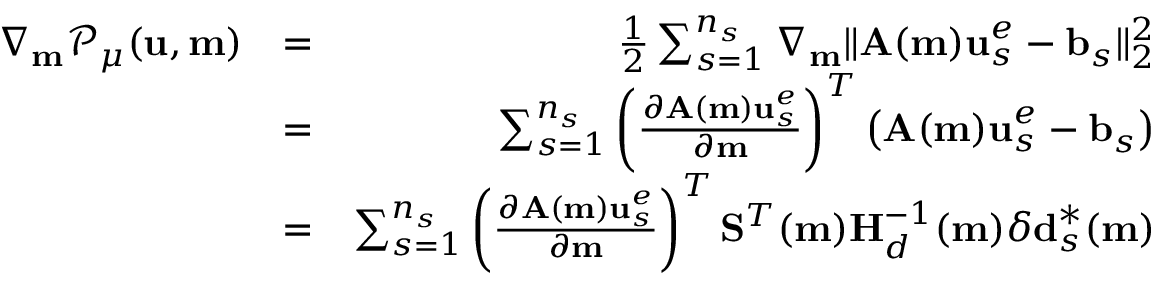<formula> <loc_0><loc_0><loc_500><loc_500>\begin{array} { r l r } { \nabla _ { m } \mathcal { P } _ { \mu } ( u , m ) } & { = } & { \frac { 1 } { 2 } \sum _ { s = 1 } ^ { n _ { s } } \nabla _ { m } \| A ( m ) u _ { s } ^ { e } - b _ { s } \| _ { 2 } ^ { 2 } } \\ & { = } & { \sum _ { s = 1 } ^ { n _ { s } } \left ( \frac { \partial A ( m ) u _ { s } ^ { e } } { \partial m } \right ) ^ { T } \left ( A ( m ) u _ { s } ^ { e } - b _ { s } \right ) } \\ & { = } & { \sum _ { s = 1 } ^ { n _ { s } } \left ( \frac { \partial A ( m ) u _ { s } ^ { e } } { \partial m } \right ) ^ { T } S ^ { T } ( m ) H _ { d } ^ { - 1 } ( m ) \delta d _ { s } ^ { * } ( m ) } \end{array}</formula> 